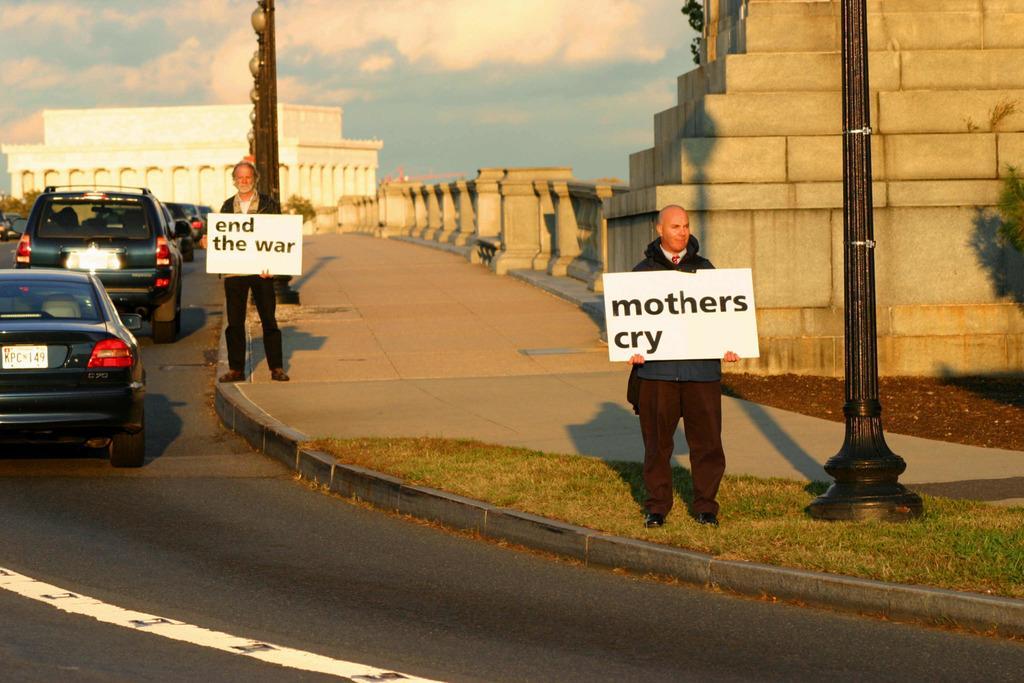In one or two sentences, can you explain what this image depicts? In this image I can see the road. On the road I can see the vehicles. To the side of the road there are two people with different color dresses. These people are holding the boards. On the boards I can see the text end the war and mothers cry is written. I can also see the poles to the side. In the background I can see the buildings, trees, clouds and the sky. 